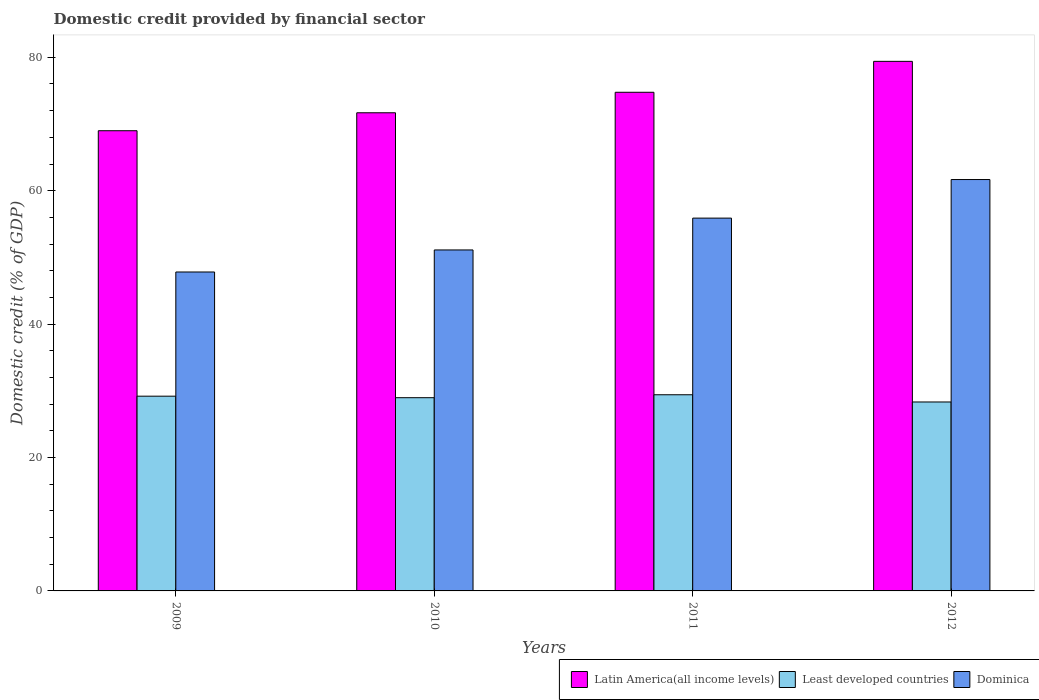Are the number of bars per tick equal to the number of legend labels?
Make the answer very short. Yes. Are the number of bars on each tick of the X-axis equal?
Provide a short and direct response. Yes. How many bars are there on the 2nd tick from the left?
Make the answer very short. 3. How many bars are there on the 3rd tick from the right?
Make the answer very short. 3. What is the label of the 1st group of bars from the left?
Keep it short and to the point. 2009. In how many cases, is the number of bars for a given year not equal to the number of legend labels?
Provide a short and direct response. 0. What is the domestic credit in Latin America(all income levels) in 2011?
Keep it short and to the point. 74.75. Across all years, what is the maximum domestic credit in Latin America(all income levels)?
Make the answer very short. 79.39. Across all years, what is the minimum domestic credit in Dominica?
Ensure brevity in your answer.  47.81. What is the total domestic credit in Least developed countries in the graph?
Your answer should be compact. 115.89. What is the difference between the domestic credit in Dominica in 2010 and that in 2011?
Offer a terse response. -4.77. What is the difference between the domestic credit in Latin America(all income levels) in 2011 and the domestic credit in Dominica in 2009?
Ensure brevity in your answer.  26.94. What is the average domestic credit in Latin America(all income levels) per year?
Ensure brevity in your answer.  73.7. In the year 2011, what is the difference between the domestic credit in Dominica and domestic credit in Latin America(all income levels)?
Make the answer very short. -18.87. What is the ratio of the domestic credit in Dominica in 2009 to that in 2012?
Offer a very short reply. 0.78. Is the difference between the domestic credit in Dominica in 2009 and 2012 greater than the difference between the domestic credit in Latin America(all income levels) in 2009 and 2012?
Give a very brief answer. No. What is the difference between the highest and the second highest domestic credit in Least developed countries?
Provide a short and direct response. 0.21. What is the difference between the highest and the lowest domestic credit in Latin America(all income levels)?
Give a very brief answer. 10.4. What does the 1st bar from the left in 2010 represents?
Keep it short and to the point. Latin America(all income levels). What does the 2nd bar from the right in 2009 represents?
Give a very brief answer. Least developed countries. Is it the case that in every year, the sum of the domestic credit in Latin America(all income levels) and domestic credit in Dominica is greater than the domestic credit in Least developed countries?
Your response must be concise. Yes. Are all the bars in the graph horizontal?
Provide a succinct answer. No. How many years are there in the graph?
Provide a short and direct response. 4. Are the values on the major ticks of Y-axis written in scientific E-notation?
Make the answer very short. No. Does the graph contain any zero values?
Provide a short and direct response. No. Where does the legend appear in the graph?
Provide a succinct answer. Bottom right. How many legend labels are there?
Give a very brief answer. 3. What is the title of the graph?
Offer a very short reply. Domestic credit provided by financial sector. Does "Honduras" appear as one of the legend labels in the graph?
Offer a terse response. No. What is the label or title of the X-axis?
Offer a very short reply. Years. What is the label or title of the Y-axis?
Keep it short and to the point. Domestic credit (% of GDP). What is the Domestic credit (% of GDP) of Latin America(all income levels) in 2009?
Your response must be concise. 68.99. What is the Domestic credit (% of GDP) in Least developed countries in 2009?
Keep it short and to the point. 29.19. What is the Domestic credit (% of GDP) in Dominica in 2009?
Give a very brief answer. 47.81. What is the Domestic credit (% of GDP) of Latin America(all income levels) in 2010?
Offer a very short reply. 71.68. What is the Domestic credit (% of GDP) of Least developed countries in 2010?
Your answer should be compact. 28.97. What is the Domestic credit (% of GDP) in Dominica in 2010?
Provide a succinct answer. 51.12. What is the Domestic credit (% of GDP) in Latin America(all income levels) in 2011?
Provide a short and direct response. 74.75. What is the Domestic credit (% of GDP) in Least developed countries in 2011?
Keep it short and to the point. 29.41. What is the Domestic credit (% of GDP) in Dominica in 2011?
Offer a terse response. 55.89. What is the Domestic credit (% of GDP) in Latin America(all income levels) in 2012?
Your answer should be very brief. 79.39. What is the Domestic credit (% of GDP) of Least developed countries in 2012?
Offer a terse response. 28.33. What is the Domestic credit (% of GDP) of Dominica in 2012?
Offer a very short reply. 61.67. Across all years, what is the maximum Domestic credit (% of GDP) in Latin America(all income levels)?
Give a very brief answer. 79.39. Across all years, what is the maximum Domestic credit (% of GDP) of Least developed countries?
Make the answer very short. 29.41. Across all years, what is the maximum Domestic credit (% of GDP) in Dominica?
Your answer should be very brief. 61.67. Across all years, what is the minimum Domestic credit (% of GDP) of Latin America(all income levels)?
Offer a very short reply. 68.99. Across all years, what is the minimum Domestic credit (% of GDP) of Least developed countries?
Provide a short and direct response. 28.33. Across all years, what is the minimum Domestic credit (% of GDP) in Dominica?
Give a very brief answer. 47.81. What is the total Domestic credit (% of GDP) in Latin America(all income levels) in the graph?
Give a very brief answer. 294.81. What is the total Domestic credit (% of GDP) of Least developed countries in the graph?
Offer a terse response. 115.89. What is the total Domestic credit (% of GDP) in Dominica in the graph?
Your answer should be very brief. 216.49. What is the difference between the Domestic credit (% of GDP) in Latin America(all income levels) in 2009 and that in 2010?
Make the answer very short. -2.69. What is the difference between the Domestic credit (% of GDP) of Least developed countries in 2009 and that in 2010?
Give a very brief answer. 0.23. What is the difference between the Domestic credit (% of GDP) in Dominica in 2009 and that in 2010?
Provide a short and direct response. -3.3. What is the difference between the Domestic credit (% of GDP) in Latin America(all income levels) in 2009 and that in 2011?
Your response must be concise. -5.77. What is the difference between the Domestic credit (% of GDP) of Least developed countries in 2009 and that in 2011?
Make the answer very short. -0.21. What is the difference between the Domestic credit (% of GDP) in Dominica in 2009 and that in 2011?
Offer a terse response. -8.08. What is the difference between the Domestic credit (% of GDP) of Latin America(all income levels) in 2009 and that in 2012?
Offer a terse response. -10.4. What is the difference between the Domestic credit (% of GDP) of Least developed countries in 2009 and that in 2012?
Keep it short and to the point. 0.87. What is the difference between the Domestic credit (% of GDP) of Dominica in 2009 and that in 2012?
Offer a terse response. -13.86. What is the difference between the Domestic credit (% of GDP) in Latin America(all income levels) in 2010 and that in 2011?
Offer a terse response. -3.07. What is the difference between the Domestic credit (% of GDP) of Least developed countries in 2010 and that in 2011?
Offer a very short reply. -0.44. What is the difference between the Domestic credit (% of GDP) of Dominica in 2010 and that in 2011?
Give a very brief answer. -4.77. What is the difference between the Domestic credit (% of GDP) in Latin America(all income levels) in 2010 and that in 2012?
Offer a terse response. -7.71. What is the difference between the Domestic credit (% of GDP) in Least developed countries in 2010 and that in 2012?
Offer a very short reply. 0.64. What is the difference between the Domestic credit (% of GDP) in Dominica in 2010 and that in 2012?
Your answer should be very brief. -10.56. What is the difference between the Domestic credit (% of GDP) in Latin America(all income levels) in 2011 and that in 2012?
Your response must be concise. -4.63. What is the difference between the Domestic credit (% of GDP) of Least developed countries in 2011 and that in 2012?
Offer a terse response. 1.08. What is the difference between the Domestic credit (% of GDP) in Dominica in 2011 and that in 2012?
Keep it short and to the point. -5.78. What is the difference between the Domestic credit (% of GDP) in Latin America(all income levels) in 2009 and the Domestic credit (% of GDP) in Least developed countries in 2010?
Provide a short and direct response. 40.02. What is the difference between the Domestic credit (% of GDP) in Latin America(all income levels) in 2009 and the Domestic credit (% of GDP) in Dominica in 2010?
Offer a terse response. 17.87. What is the difference between the Domestic credit (% of GDP) in Least developed countries in 2009 and the Domestic credit (% of GDP) in Dominica in 2010?
Make the answer very short. -21.92. What is the difference between the Domestic credit (% of GDP) in Latin America(all income levels) in 2009 and the Domestic credit (% of GDP) in Least developed countries in 2011?
Ensure brevity in your answer.  39.58. What is the difference between the Domestic credit (% of GDP) of Latin America(all income levels) in 2009 and the Domestic credit (% of GDP) of Dominica in 2011?
Ensure brevity in your answer.  13.1. What is the difference between the Domestic credit (% of GDP) in Least developed countries in 2009 and the Domestic credit (% of GDP) in Dominica in 2011?
Your answer should be compact. -26.69. What is the difference between the Domestic credit (% of GDP) in Latin America(all income levels) in 2009 and the Domestic credit (% of GDP) in Least developed countries in 2012?
Keep it short and to the point. 40.66. What is the difference between the Domestic credit (% of GDP) of Latin America(all income levels) in 2009 and the Domestic credit (% of GDP) of Dominica in 2012?
Provide a succinct answer. 7.32. What is the difference between the Domestic credit (% of GDP) in Least developed countries in 2009 and the Domestic credit (% of GDP) in Dominica in 2012?
Your answer should be compact. -32.48. What is the difference between the Domestic credit (% of GDP) of Latin America(all income levels) in 2010 and the Domestic credit (% of GDP) of Least developed countries in 2011?
Offer a terse response. 42.27. What is the difference between the Domestic credit (% of GDP) of Latin America(all income levels) in 2010 and the Domestic credit (% of GDP) of Dominica in 2011?
Offer a very short reply. 15.79. What is the difference between the Domestic credit (% of GDP) in Least developed countries in 2010 and the Domestic credit (% of GDP) in Dominica in 2011?
Give a very brief answer. -26.92. What is the difference between the Domestic credit (% of GDP) of Latin America(all income levels) in 2010 and the Domestic credit (% of GDP) of Least developed countries in 2012?
Provide a short and direct response. 43.35. What is the difference between the Domestic credit (% of GDP) of Latin America(all income levels) in 2010 and the Domestic credit (% of GDP) of Dominica in 2012?
Keep it short and to the point. 10.01. What is the difference between the Domestic credit (% of GDP) of Least developed countries in 2010 and the Domestic credit (% of GDP) of Dominica in 2012?
Offer a terse response. -32.7. What is the difference between the Domestic credit (% of GDP) of Latin America(all income levels) in 2011 and the Domestic credit (% of GDP) of Least developed countries in 2012?
Your answer should be compact. 46.43. What is the difference between the Domestic credit (% of GDP) in Latin America(all income levels) in 2011 and the Domestic credit (% of GDP) in Dominica in 2012?
Your answer should be compact. 13.08. What is the difference between the Domestic credit (% of GDP) of Least developed countries in 2011 and the Domestic credit (% of GDP) of Dominica in 2012?
Offer a terse response. -32.26. What is the average Domestic credit (% of GDP) in Latin America(all income levels) per year?
Offer a very short reply. 73.7. What is the average Domestic credit (% of GDP) in Least developed countries per year?
Make the answer very short. 28.97. What is the average Domestic credit (% of GDP) of Dominica per year?
Provide a succinct answer. 54.12. In the year 2009, what is the difference between the Domestic credit (% of GDP) in Latin America(all income levels) and Domestic credit (% of GDP) in Least developed countries?
Your response must be concise. 39.79. In the year 2009, what is the difference between the Domestic credit (% of GDP) of Latin America(all income levels) and Domestic credit (% of GDP) of Dominica?
Keep it short and to the point. 21.18. In the year 2009, what is the difference between the Domestic credit (% of GDP) in Least developed countries and Domestic credit (% of GDP) in Dominica?
Your answer should be very brief. -18.62. In the year 2010, what is the difference between the Domestic credit (% of GDP) of Latin America(all income levels) and Domestic credit (% of GDP) of Least developed countries?
Your answer should be very brief. 42.71. In the year 2010, what is the difference between the Domestic credit (% of GDP) of Latin America(all income levels) and Domestic credit (% of GDP) of Dominica?
Your answer should be compact. 20.56. In the year 2010, what is the difference between the Domestic credit (% of GDP) of Least developed countries and Domestic credit (% of GDP) of Dominica?
Your answer should be compact. -22.15. In the year 2011, what is the difference between the Domestic credit (% of GDP) in Latin America(all income levels) and Domestic credit (% of GDP) in Least developed countries?
Provide a succinct answer. 45.35. In the year 2011, what is the difference between the Domestic credit (% of GDP) of Latin America(all income levels) and Domestic credit (% of GDP) of Dominica?
Keep it short and to the point. 18.87. In the year 2011, what is the difference between the Domestic credit (% of GDP) in Least developed countries and Domestic credit (% of GDP) in Dominica?
Ensure brevity in your answer.  -26.48. In the year 2012, what is the difference between the Domestic credit (% of GDP) in Latin America(all income levels) and Domestic credit (% of GDP) in Least developed countries?
Your answer should be very brief. 51.06. In the year 2012, what is the difference between the Domestic credit (% of GDP) in Latin America(all income levels) and Domestic credit (% of GDP) in Dominica?
Give a very brief answer. 17.72. In the year 2012, what is the difference between the Domestic credit (% of GDP) of Least developed countries and Domestic credit (% of GDP) of Dominica?
Your answer should be very brief. -33.35. What is the ratio of the Domestic credit (% of GDP) in Latin America(all income levels) in 2009 to that in 2010?
Offer a very short reply. 0.96. What is the ratio of the Domestic credit (% of GDP) of Dominica in 2009 to that in 2010?
Provide a succinct answer. 0.94. What is the ratio of the Domestic credit (% of GDP) in Latin America(all income levels) in 2009 to that in 2011?
Make the answer very short. 0.92. What is the ratio of the Domestic credit (% of GDP) of Least developed countries in 2009 to that in 2011?
Keep it short and to the point. 0.99. What is the ratio of the Domestic credit (% of GDP) in Dominica in 2009 to that in 2011?
Make the answer very short. 0.86. What is the ratio of the Domestic credit (% of GDP) in Latin America(all income levels) in 2009 to that in 2012?
Your response must be concise. 0.87. What is the ratio of the Domestic credit (% of GDP) in Least developed countries in 2009 to that in 2012?
Offer a terse response. 1.03. What is the ratio of the Domestic credit (% of GDP) of Dominica in 2009 to that in 2012?
Give a very brief answer. 0.78. What is the ratio of the Domestic credit (% of GDP) of Latin America(all income levels) in 2010 to that in 2011?
Ensure brevity in your answer.  0.96. What is the ratio of the Domestic credit (% of GDP) in Dominica in 2010 to that in 2011?
Make the answer very short. 0.91. What is the ratio of the Domestic credit (% of GDP) of Latin America(all income levels) in 2010 to that in 2012?
Provide a short and direct response. 0.9. What is the ratio of the Domestic credit (% of GDP) of Least developed countries in 2010 to that in 2012?
Keep it short and to the point. 1.02. What is the ratio of the Domestic credit (% of GDP) in Dominica in 2010 to that in 2012?
Provide a short and direct response. 0.83. What is the ratio of the Domestic credit (% of GDP) of Latin America(all income levels) in 2011 to that in 2012?
Your response must be concise. 0.94. What is the ratio of the Domestic credit (% of GDP) in Least developed countries in 2011 to that in 2012?
Provide a succinct answer. 1.04. What is the ratio of the Domestic credit (% of GDP) of Dominica in 2011 to that in 2012?
Give a very brief answer. 0.91. What is the difference between the highest and the second highest Domestic credit (% of GDP) of Latin America(all income levels)?
Provide a succinct answer. 4.63. What is the difference between the highest and the second highest Domestic credit (% of GDP) of Least developed countries?
Your answer should be compact. 0.21. What is the difference between the highest and the second highest Domestic credit (% of GDP) of Dominica?
Give a very brief answer. 5.78. What is the difference between the highest and the lowest Domestic credit (% of GDP) in Latin America(all income levels)?
Give a very brief answer. 10.4. What is the difference between the highest and the lowest Domestic credit (% of GDP) of Least developed countries?
Provide a succinct answer. 1.08. What is the difference between the highest and the lowest Domestic credit (% of GDP) in Dominica?
Your response must be concise. 13.86. 